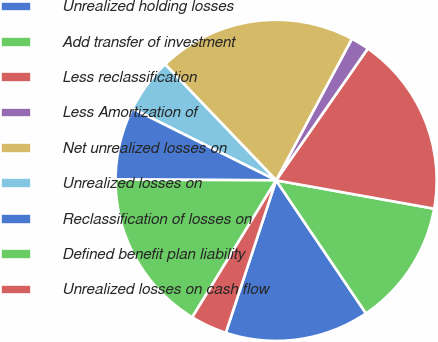Convert chart to OTSL. <chart><loc_0><loc_0><loc_500><loc_500><pie_chart><fcel>Unrealized holding losses<fcel>Add transfer of investment<fcel>Less reclassification<fcel>Less Amortization of<fcel>Net unrealized losses on<fcel>Unrealized losses on<fcel>Reclassification of losses on<fcel>Defined benefit plan liability<fcel>Unrealized losses on cash flow<nl><fcel>14.53%<fcel>12.72%<fcel>18.15%<fcel>1.85%<fcel>19.97%<fcel>5.48%<fcel>7.29%<fcel>16.34%<fcel>3.67%<nl></chart> 